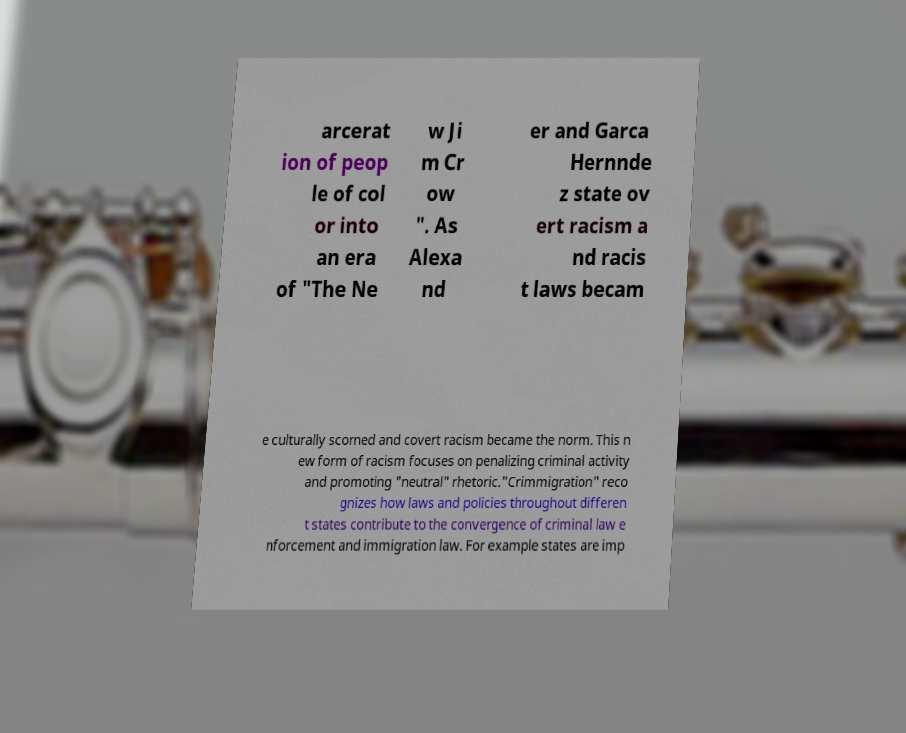Could you assist in decoding the text presented in this image and type it out clearly? arcerat ion of peop le of col or into an era of "The Ne w Ji m Cr ow ". As Alexa nd er and Garca Hernnde z state ov ert racism a nd racis t laws becam e culturally scorned and covert racism became the norm. This n ew form of racism focuses on penalizing criminal activity and promoting "neutral" rhetoric."Crimmigration" reco gnizes how laws and policies throughout differen t states contribute to the convergence of criminal law e nforcement and immigration law. For example states are imp 